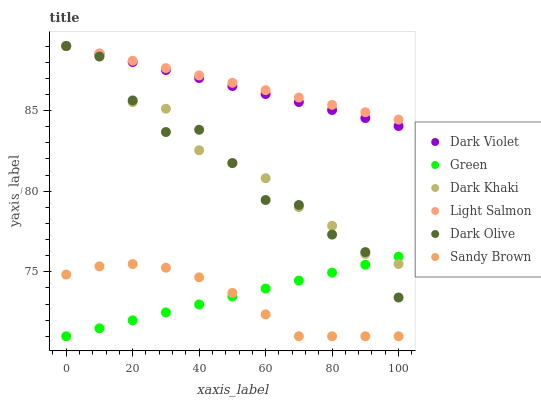Does Sandy Brown have the minimum area under the curve?
Answer yes or no. Yes. Does Light Salmon have the maximum area under the curve?
Answer yes or no. Yes. Does Dark Olive have the minimum area under the curve?
Answer yes or no. No. Does Dark Olive have the maximum area under the curve?
Answer yes or no. No. Is Light Salmon the smoothest?
Answer yes or no. Yes. Is Dark Olive the roughest?
Answer yes or no. Yes. Is Dark Violet the smoothest?
Answer yes or no. No. Is Dark Violet the roughest?
Answer yes or no. No. Does Green have the lowest value?
Answer yes or no. Yes. Does Dark Olive have the lowest value?
Answer yes or no. No. Does Dark Khaki have the highest value?
Answer yes or no. Yes. Does Green have the highest value?
Answer yes or no. No. Is Sandy Brown less than Light Salmon?
Answer yes or no. Yes. Is Light Salmon greater than Sandy Brown?
Answer yes or no. Yes. Does Dark Violet intersect Dark Khaki?
Answer yes or no. Yes. Is Dark Violet less than Dark Khaki?
Answer yes or no. No. Is Dark Violet greater than Dark Khaki?
Answer yes or no. No. Does Sandy Brown intersect Light Salmon?
Answer yes or no. No. 